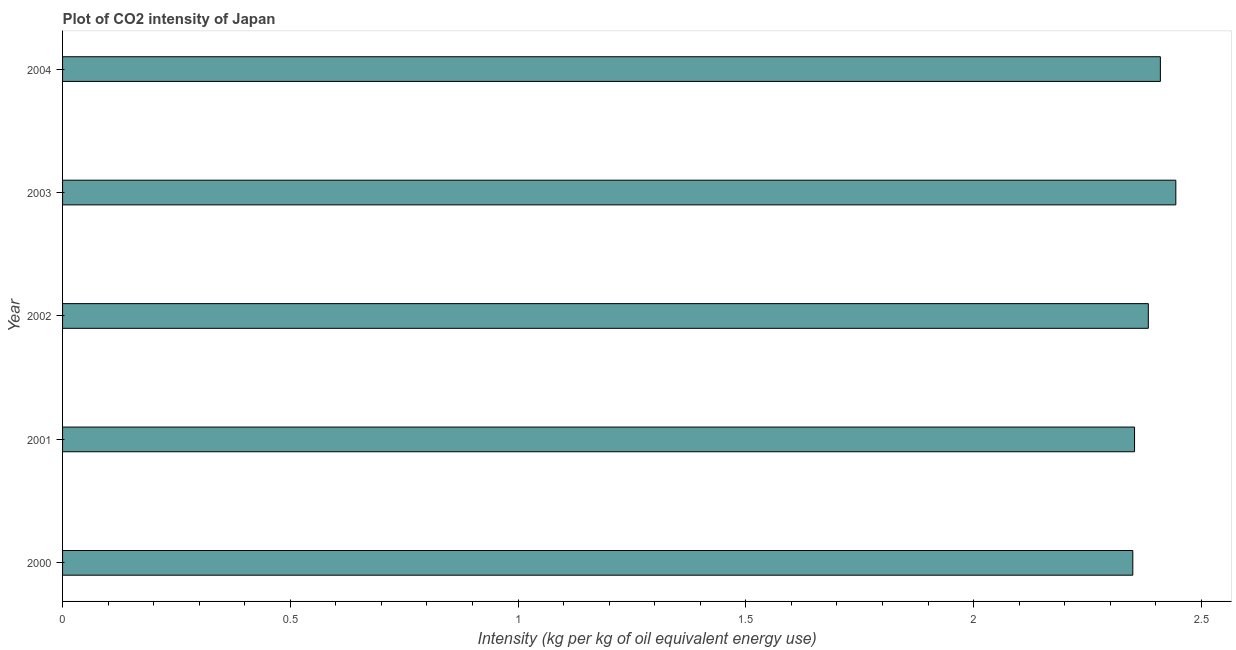Does the graph contain any zero values?
Provide a succinct answer. No. What is the title of the graph?
Provide a short and direct response. Plot of CO2 intensity of Japan. What is the label or title of the X-axis?
Ensure brevity in your answer.  Intensity (kg per kg of oil equivalent energy use). What is the co2 intensity in 2001?
Provide a short and direct response. 2.35. Across all years, what is the maximum co2 intensity?
Your answer should be very brief. 2.44. Across all years, what is the minimum co2 intensity?
Your response must be concise. 2.35. In which year was the co2 intensity maximum?
Provide a short and direct response. 2003. What is the sum of the co2 intensity?
Make the answer very short. 11.94. What is the difference between the co2 intensity in 2000 and 2001?
Give a very brief answer. -0. What is the average co2 intensity per year?
Your response must be concise. 2.39. What is the median co2 intensity?
Your answer should be compact. 2.38. Do a majority of the years between 2000 and 2001 (inclusive) have co2 intensity greater than 1.4 kg?
Your answer should be very brief. Yes. What is the ratio of the co2 intensity in 2002 to that in 2003?
Provide a succinct answer. 0.97. Is the co2 intensity in 2000 less than that in 2003?
Give a very brief answer. Yes. Is the difference between the co2 intensity in 2001 and 2003 greater than the difference between any two years?
Your answer should be very brief. No. What is the difference between the highest and the second highest co2 intensity?
Offer a very short reply. 0.03. Is the sum of the co2 intensity in 2000 and 2004 greater than the maximum co2 intensity across all years?
Provide a succinct answer. Yes. What is the difference between the highest and the lowest co2 intensity?
Your response must be concise. 0.09. What is the Intensity (kg per kg of oil equivalent energy use) in 2000?
Your response must be concise. 2.35. What is the Intensity (kg per kg of oil equivalent energy use) of 2001?
Your response must be concise. 2.35. What is the Intensity (kg per kg of oil equivalent energy use) of 2002?
Your answer should be very brief. 2.38. What is the Intensity (kg per kg of oil equivalent energy use) in 2003?
Provide a succinct answer. 2.44. What is the Intensity (kg per kg of oil equivalent energy use) in 2004?
Keep it short and to the point. 2.41. What is the difference between the Intensity (kg per kg of oil equivalent energy use) in 2000 and 2001?
Make the answer very short. -0. What is the difference between the Intensity (kg per kg of oil equivalent energy use) in 2000 and 2002?
Ensure brevity in your answer.  -0.03. What is the difference between the Intensity (kg per kg of oil equivalent energy use) in 2000 and 2003?
Provide a succinct answer. -0.09. What is the difference between the Intensity (kg per kg of oil equivalent energy use) in 2000 and 2004?
Your answer should be compact. -0.06. What is the difference between the Intensity (kg per kg of oil equivalent energy use) in 2001 and 2002?
Keep it short and to the point. -0.03. What is the difference between the Intensity (kg per kg of oil equivalent energy use) in 2001 and 2003?
Offer a terse response. -0.09. What is the difference between the Intensity (kg per kg of oil equivalent energy use) in 2001 and 2004?
Your answer should be compact. -0.06. What is the difference between the Intensity (kg per kg of oil equivalent energy use) in 2002 and 2003?
Provide a short and direct response. -0.06. What is the difference between the Intensity (kg per kg of oil equivalent energy use) in 2002 and 2004?
Your answer should be compact. -0.03. What is the difference between the Intensity (kg per kg of oil equivalent energy use) in 2003 and 2004?
Offer a terse response. 0.03. What is the ratio of the Intensity (kg per kg of oil equivalent energy use) in 2000 to that in 2001?
Keep it short and to the point. 1. What is the ratio of the Intensity (kg per kg of oil equivalent energy use) in 2000 to that in 2004?
Ensure brevity in your answer.  0.97. What is the ratio of the Intensity (kg per kg of oil equivalent energy use) in 2001 to that in 2002?
Your answer should be compact. 0.99. What is the ratio of the Intensity (kg per kg of oil equivalent energy use) in 2001 to that in 2003?
Offer a terse response. 0.96. What is the ratio of the Intensity (kg per kg of oil equivalent energy use) in 2003 to that in 2004?
Offer a terse response. 1.01. 